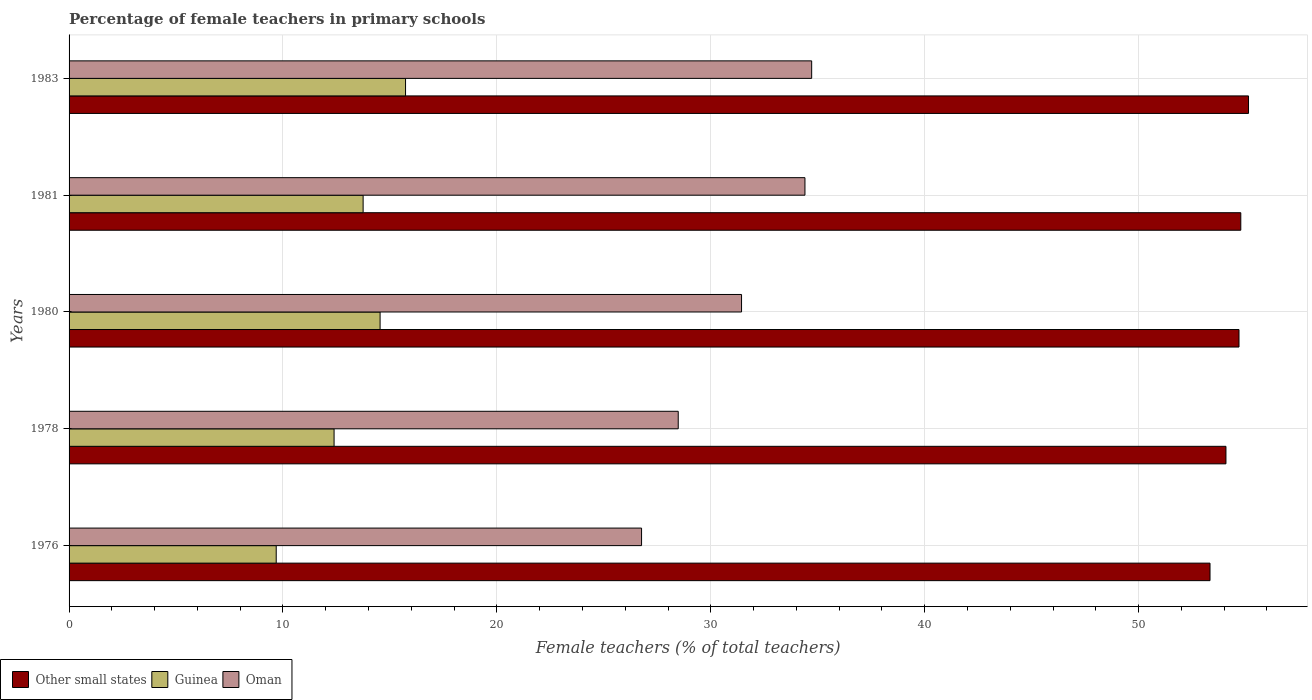How many different coloured bars are there?
Keep it short and to the point. 3. How many groups of bars are there?
Provide a short and direct response. 5. Are the number of bars on each tick of the Y-axis equal?
Your answer should be very brief. Yes. How many bars are there on the 4th tick from the top?
Offer a terse response. 3. In how many cases, is the number of bars for a given year not equal to the number of legend labels?
Your answer should be compact. 0. What is the percentage of female teachers in Oman in 1983?
Offer a very short reply. 34.72. Across all years, what is the maximum percentage of female teachers in Oman?
Make the answer very short. 34.72. Across all years, what is the minimum percentage of female teachers in Guinea?
Give a very brief answer. 9.68. In which year was the percentage of female teachers in Other small states minimum?
Provide a succinct answer. 1976. What is the total percentage of female teachers in Oman in the graph?
Ensure brevity in your answer.  155.8. What is the difference between the percentage of female teachers in Oman in 1976 and that in 1980?
Offer a terse response. -4.67. What is the difference between the percentage of female teachers in Oman in 1981 and the percentage of female teachers in Guinea in 1980?
Your answer should be compact. 19.86. What is the average percentage of female teachers in Guinea per year?
Make the answer very short. 13.22. In the year 1981, what is the difference between the percentage of female teachers in Guinea and percentage of female teachers in Other small states?
Provide a short and direct response. -41.03. In how many years, is the percentage of female teachers in Oman greater than 50 %?
Keep it short and to the point. 0. What is the ratio of the percentage of female teachers in Oman in 1980 to that in 1983?
Provide a succinct answer. 0.91. Is the percentage of female teachers in Oman in 1976 less than that in 1980?
Provide a short and direct response. Yes. What is the difference between the highest and the second highest percentage of female teachers in Guinea?
Offer a terse response. 1.19. What is the difference between the highest and the lowest percentage of female teachers in Guinea?
Your response must be concise. 6.05. In how many years, is the percentage of female teachers in Other small states greater than the average percentage of female teachers in Other small states taken over all years?
Your answer should be compact. 3. Is the sum of the percentage of female teachers in Other small states in 1978 and 1983 greater than the maximum percentage of female teachers in Guinea across all years?
Your answer should be compact. Yes. What does the 2nd bar from the top in 1978 represents?
Your answer should be compact. Guinea. What does the 3rd bar from the bottom in 1983 represents?
Keep it short and to the point. Oman. Is it the case that in every year, the sum of the percentage of female teachers in Other small states and percentage of female teachers in Guinea is greater than the percentage of female teachers in Oman?
Offer a terse response. Yes. Are all the bars in the graph horizontal?
Give a very brief answer. Yes. How many years are there in the graph?
Your answer should be very brief. 5. What is the difference between two consecutive major ticks on the X-axis?
Provide a succinct answer. 10. Where does the legend appear in the graph?
Offer a very short reply. Bottom left. How are the legend labels stacked?
Offer a very short reply. Horizontal. What is the title of the graph?
Your answer should be very brief. Percentage of female teachers in primary schools. Does "Fragile and conflict affected situations" appear as one of the legend labels in the graph?
Ensure brevity in your answer.  No. What is the label or title of the X-axis?
Provide a short and direct response. Female teachers (% of total teachers). What is the Female teachers (% of total teachers) of Other small states in 1976?
Provide a short and direct response. 53.34. What is the Female teachers (% of total teachers) in Guinea in 1976?
Keep it short and to the point. 9.68. What is the Female teachers (% of total teachers) of Oman in 1976?
Provide a succinct answer. 26.76. What is the Female teachers (% of total teachers) in Other small states in 1978?
Your answer should be very brief. 54.08. What is the Female teachers (% of total teachers) of Guinea in 1978?
Give a very brief answer. 12.39. What is the Female teachers (% of total teachers) in Oman in 1978?
Provide a short and direct response. 28.48. What is the Female teachers (% of total teachers) of Other small states in 1980?
Offer a very short reply. 54.69. What is the Female teachers (% of total teachers) of Guinea in 1980?
Your response must be concise. 14.54. What is the Female teachers (% of total teachers) of Oman in 1980?
Give a very brief answer. 31.44. What is the Female teachers (% of total teachers) of Other small states in 1981?
Provide a succinct answer. 54.78. What is the Female teachers (% of total teachers) in Guinea in 1981?
Provide a succinct answer. 13.75. What is the Female teachers (% of total teachers) in Oman in 1981?
Offer a terse response. 34.4. What is the Female teachers (% of total teachers) of Other small states in 1983?
Offer a terse response. 55.14. What is the Female teachers (% of total teachers) of Guinea in 1983?
Ensure brevity in your answer.  15.73. What is the Female teachers (% of total teachers) in Oman in 1983?
Ensure brevity in your answer.  34.72. Across all years, what is the maximum Female teachers (% of total teachers) of Other small states?
Offer a very short reply. 55.14. Across all years, what is the maximum Female teachers (% of total teachers) of Guinea?
Give a very brief answer. 15.73. Across all years, what is the maximum Female teachers (% of total teachers) of Oman?
Make the answer very short. 34.72. Across all years, what is the minimum Female teachers (% of total teachers) in Other small states?
Your answer should be compact. 53.34. Across all years, what is the minimum Female teachers (% of total teachers) in Guinea?
Ensure brevity in your answer.  9.68. Across all years, what is the minimum Female teachers (% of total teachers) in Oman?
Your answer should be very brief. 26.76. What is the total Female teachers (% of total teachers) in Other small states in the graph?
Your answer should be very brief. 272.04. What is the total Female teachers (% of total teachers) of Guinea in the graph?
Provide a succinct answer. 66.09. What is the total Female teachers (% of total teachers) of Oman in the graph?
Your answer should be compact. 155.8. What is the difference between the Female teachers (% of total teachers) of Other small states in 1976 and that in 1978?
Your answer should be very brief. -0.75. What is the difference between the Female teachers (% of total teachers) of Guinea in 1976 and that in 1978?
Make the answer very short. -2.7. What is the difference between the Female teachers (% of total teachers) in Oman in 1976 and that in 1978?
Your answer should be very brief. -1.71. What is the difference between the Female teachers (% of total teachers) of Other small states in 1976 and that in 1980?
Provide a short and direct response. -1.36. What is the difference between the Female teachers (% of total teachers) of Guinea in 1976 and that in 1980?
Make the answer very short. -4.86. What is the difference between the Female teachers (% of total teachers) in Oman in 1976 and that in 1980?
Ensure brevity in your answer.  -4.67. What is the difference between the Female teachers (% of total teachers) in Other small states in 1976 and that in 1981?
Ensure brevity in your answer.  -1.44. What is the difference between the Female teachers (% of total teachers) in Guinea in 1976 and that in 1981?
Offer a terse response. -4.06. What is the difference between the Female teachers (% of total teachers) of Oman in 1976 and that in 1981?
Ensure brevity in your answer.  -7.64. What is the difference between the Female teachers (% of total teachers) in Other small states in 1976 and that in 1983?
Your response must be concise. -1.8. What is the difference between the Female teachers (% of total teachers) in Guinea in 1976 and that in 1983?
Provide a short and direct response. -6.05. What is the difference between the Female teachers (% of total teachers) of Oman in 1976 and that in 1983?
Give a very brief answer. -7.95. What is the difference between the Female teachers (% of total teachers) in Other small states in 1978 and that in 1980?
Keep it short and to the point. -0.61. What is the difference between the Female teachers (% of total teachers) in Guinea in 1978 and that in 1980?
Offer a very short reply. -2.15. What is the difference between the Female teachers (% of total teachers) in Oman in 1978 and that in 1980?
Provide a short and direct response. -2.96. What is the difference between the Female teachers (% of total teachers) in Other small states in 1978 and that in 1981?
Make the answer very short. -0.69. What is the difference between the Female teachers (% of total teachers) in Guinea in 1978 and that in 1981?
Your response must be concise. -1.36. What is the difference between the Female teachers (% of total teachers) of Oman in 1978 and that in 1981?
Keep it short and to the point. -5.92. What is the difference between the Female teachers (% of total teachers) of Other small states in 1978 and that in 1983?
Your answer should be very brief. -1.05. What is the difference between the Female teachers (% of total teachers) of Guinea in 1978 and that in 1983?
Provide a short and direct response. -3.34. What is the difference between the Female teachers (% of total teachers) of Oman in 1978 and that in 1983?
Your answer should be compact. -6.24. What is the difference between the Female teachers (% of total teachers) of Other small states in 1980 and that in 1981?
Give a very brief answer. -0.08. What is the difference between the Female teachers (% of total teachers) in Guinea in 1980 and that in 1981?
Provide a succinct answer. 0.79. What is the difference between the Female teachers (% of total teachers) in Oman in 1980 and that in 1981?
Your answer should be compact. -2.96. What is the difference between the Female teachers (% of total teachers) of Other small states in 1980 and that in 1983?
Ensure brevity in your answer.  -0.44. What is the difference between the Female teachers (% of total teachers) of Guinea in 1980 and that in 1983?
Keep it short and to the point. -1.19. What is the difference between the Female teachers (% of total teachers) in Oman in 1980 and that in 1983?
Make the answer very short. -3.28. What is the difference between the Female teachers (% of total teachers) of Other small states in 1981 and that in 1983?
Offer a terse response. -0.36. What is the difference between the Female teachers (% of total teachers) of Guinea in 1981 and that in 1983?
Your answer should be very brief. -1.98. What is the difference between the Female teachers (% of total teachers) of Oman in 1981 and that in 1983?
Make the answer very short. -0.31. What is the difference between the Female teachers (% of total teachers) of Other small states in 1976 and the Female teachers (% of total teachers) of Guinea in 1978?
Offer a terse response. 40.95. What is the difference between the Female teachers (% of total teachers) of Other small states in 1976 and the Female teachers (% of total teachers) of Oman in 1978?
Provide a succinct answer. 24.86. What is the difference between the Female teachers (% of total teachers) of Guinea in 1976 and the Female teachers (% of total teachers) of Oman in 1978?
Your answer should be very brief. -18.79. What is the difference between the Female teachers (% of total teachers) in Other small states in 1976 and the Female teachers (% of total teachers) in Guinea in 1980?
Ensure brevity in your answer.  38.8. What is the difference between the Female teachers (% of total teachers) in Other small states in 1976 and the Female teachers (% of total teachers) in Oman in 1980?
Offer a terse response. 21.9. What is the difference between the Female teachers (% of total teachers) in Guinea in 1976 and the Female teachers (% of total teachers) in Oman in 1980?
Your answer should be compact. -21.75. What is the difference between the Female teachers (% of total teachers) of Other small states in 1976 and the Female teachers (% of total teachers) of Guinea in 1981?
Make the answer very short. 39.59. What is the difference between the Female teachers (% of total teachers) of Other small states in 1976 and the Female teachers (% of total teachers) of Oman in 1981?
Ensure brevity in your answer.  18.94. What is the difference between the Female teachers (% of total teachers) in Guinea in 1976 and the Female teachers (% of total teachers) in Oman in 1981?
Offer a terse response. -24.72. What is the difference between the Female teachers (% of total teachers) in Other small states in 1976 and the Female teachers (% of total teachers) in Guinea in 1983?
Offer a very short reply. 37.61. What is the difference between the Female teachers (% of total teachers) in Other small states in 1976 and the Female teachers (% of total teachers) in Oman in 1983?
Offer a terse response. 18.62. What is the difference between the Female teachers (% of total teachers) in Guinea in 1976 and the Female teachers (% of total teachers) in Oman in 1983?
Provide a succinct answer. -25.03. What is the difference between the Female teachers (% of total teachers) of Other small states in 1978 and the Female teachers (% of total teachers) of Guinea in 1980?
Make the answer very short. 39.54. What is the difference between the Female teachers (% of total teachers) in Other small states in 1978 and the Female teachers (% of total teachers) in Oman in 1980?
Offer a terse response. 22.65. What is the difference between the Female teachers (% of total teachers) in Guinea in 1978 and the Female teachers (% of total teachers) in Oman in 1980?
Offer a very short reply. -19.05. What is the difference between the Female teachers (% of total teachers) in Other small states in 1978 and the Female teachers (% of total teachers) in Guinea in 1981?
Offer a very short reply. 40.34. What is the difference between the Female teachers (% of total teachers) of Other small states in 1978 and the Female teachers (% of total teachers) of Oman in 1981?
Give a very brief answer. 19.68. What is the difference between the Female teachers (% of total teachers) in Guinea in 1978 and the Female teachers (% of total teachers) in Oman in 1981?
Offer a very short reply. -22.01. What is the difference between the Female teachers (% of total teachers) in Other small states in 1978 and the Female teachers (% of total teachers) in Guinea in 1983?
Offer a very short reply. 38.35. What is the difference between the Female teachers (% of total teachers) in Other small states in 1978 and the Female teachers (% of total teachers) in Oman in 1983?
Offer a very short reply. 19.37. What is the difference between the Female teachers (% of total teachers) in Guinea in 1978 and the Female teachers (% of total teachers) in Oman in 1983?
Keep it short and to the point. -22.33. What is the difference between the Female teachers (% of total teachers) of Other small states in 1980 and the Female teachers (% of total teachers) of Guinea in 1981?
Give a very brief answer. 40.95. What is the difference between the Female teachers (% of total teachers) in Other small states in 1980 and the Female teachers (% of total teachers) in Oman in 1981?
Make the answer very short. 20.29. What is the difference between the Female teachers (% of total teachers) in Guinea in 1980 and the Female teachers (% of total teachers) in Oman in 1981?
Provide a short and direct response. -19.86. What is the difference between the Female teachers (% of total teachers) of Other small states in 1980 and the Female teachers (% of total teachers) of Guinea in 1983?
Provide a short and direct response. 38.96. What is the difference between the Female teachers (% of total teachers) of Other small states in 1980 and the Female teachers (% of total teachers) of Oman in 1983?
Your response must be concise. 19.98. What is the difference between the Female teachers (% of total teachers) in Guinea in 1980 and the Female teachers (% of total teachers) in Oman in 1983?
Offer a very short reply. -20.18. What is the difference between the Female teachers (% of total teachers) in Other small states in 1981 and the Female teachers (% of total teachers) in Guinea in 1983?
Make the answer very short. 39.05. What is the difference between the Female teachers (% of total teachers) in Other small states in 1981 and the Female teachers (% of total teachers) in Oman in 1983?
Offer a terse response. 20.06. What is the difference between the Female teachers (% of total teachers) of Guinea in 1981 and the Female teachers (% of total teachers) of Oman in 1983?
Ensure brevity in your answer.  -20.97. What is the average Female teachers (% of total teachers) of Other small states per year?
Provide a succinct answer. 54.41. What is the average Female teachers (% of total teachers) in Guinea per year?
Make the answer very short. 13.22. What is the average Female teachers (% of total teachers) in Oman per year?
Your answer should be very brief. 31.16. In the year 1976, what is the difference between the Female teachers (% of total teachers) in Other small states and Female teachers (% of total teachers) in Guinea?
Ensure brevity in your answer.  43.66. In the year 1976, what is the difference between the Female teachers (% of total teachers) in Other small states and Female teachers (% of total teachers) in Oman?
Give a very brief answer. 26.58. In the year 1976, what is the difference between the Female teachers (% of total teachers) of Guinea and Female teachers (% of total teachers) of Oman?
Your answer should be compact. -17.08. In the year 1978, what is the difference between the Female teachers (% of total teachers) of Other small states and Female teachers (% of total teachers) of Guinea?
Keep it short and to the point. 41.7. In the year 1978, what is the difference between the Female teachers (% of total teachers) in Other small states and Female teachers (% of total teachers) in Oman?
Offer a very short reply. 25.61. In the year 1978, what is the difference between the Female teachers (% of total teachers) in Guinea and Female teachers (% of total teachers) in Oman?
Make the answer very short. -16.09. In the year 1980, what is the difference between the Female teachers (% of total teachers) in Other small states and Female teachers (% of total teachers) in Guinea?
Make the answer very short. 40.15. In the year 1980, what is the difference between the Female teachers (% of total teachers) of Other small states and Female teachers (% of total teachers) of Oman?
Your answer should be very brief. 23.26. In the year 1980, what is the difference between the Female teachers (% of total teachers) of Guinea and Female teachers (% of total teachers) of Oman?
Offer a very short reply. -16.9. In the year 1981, what is the difference between the Female teachers (% of total teachers) of Other small states and Female teachers (% of total teachers) of Guinea?
Your answer should be very brief. 41.03. In the year 1981, what is the difference between the Female teachers (% of total teachers) of Other small states and Female teachers (% of total teachers) of Oman?
Provide a succinct answer. 20.38. In the year 1981, what is the difference between the Female teachers (% of total teachers) of Guinea and Female teachers (% of total teachers) of Oman?
Provide a short and direct response. -20.66. In the year 1983, what is the difference between the Female teachers (% of total teachers) in Other small states and Female teachers (% of total teachers) in Guinea?
Your answer should be compact. 39.41. In the year 1983, what is the difference between the Female teachers (% of total teachers) of Other small states and Female teachers (% of total teachers) of Oman?
Provide a succinct answer. 20.42. In the year 1983, what is the difference between the Female teachers (% of total teachers) of Guinea and Female teachers (% of total teachers) of Oman?
Keep it short and to the point. -18.99. What is the ratio of the Female teachers (% of total teachers) of Other small states in 1976 to that in 1978?
Offer a terse response. 0.99. What is the ratio of the Female teachers (% of total teachers) of Guinea in 1976 to that in 1978?
Your response must be concise. 0.78. What is the ratio of the Female teachers (% of total teachers) in Oman in 1976 to that in 1978?
Offer a very short reply. 0.94. What is the ratio of the Female teachers (% of total teachers) of Other small states in 1976 to that in 1980?
Keep it short and to the point. 0.98. What is the ratio of the Female teachers (% of total teachers) in Guinea in 1976 to that in 1980?
Make the answer very short. 0.67. What is the ratio of the Female teachers (% of total teachers) in Oman in 1976 to that in 1980?
Provide a short and direct response. 0.85. What is the ratio of the Female teachers (% of total teachers) of Other small states in 1976 to that in 1981?
Keep it short and to the point. 0.97. What is the ratio of the Female teachers (% of total teachers) in Guinea in 1976 to that in 1981?
Give a very brief answer. 0.7. What is the ratio of the Female teachers (% of total teachers) of Oman in 1976 to that in 1981?
Your answer should be compact. 0.78. What is the ratio of the Female teachers (% of total teachers) of Other small states in 1976 to that in 1983?
Offer a terse response. 0.97. What is the ratio of the Female teachers (% of total teachers) of Guinea in 1976 to that in 1983?
Your response must be concise. 0.62. What is the ratio of the Female teachers (% of total teachers) of Oman in 1976 to that in 1983?
Your answer should be compact. 0.77. What is the ratio of the Female teachers (% of total teachers) of Other small states in 1978 to that in 1980?
Your response must be concise. 0.99. What is the ratio of the Female teachers (% of total teachers) in Guinea in 1978 to that in 1980?
Make the answer very short. 0.85. What is the ratio of the Female teachers (% of total teachers) in Oman in 1978 to that in 1980?
Your answer should be very brief. 0.91. What is the ratio of the Female teachers (% of total teachers) in Other small states in 1978 to that in 1981?
Ensure brevity in your answer.  0.99. What is the ratio of the Female teachers (% of total teachers) of Guinea in 1978 to that in 1981?
Your answer should be compact. 0.9. What is the ratio of the Female teachers (% of total teachers) of Oman in 1978 to that in 1981?
Provide a short and direct response. 0.83. What is the ratio of the Female teachers (% of total teachers) of Other small states in 1978 to that in 1983?
Keep it short and to the point. 0.98. What is the ratio of the Female teachers (% of total teachers) in Guinea in 1978 to that in 1983?
Your answer should be very brief. 0.79. What is the ratio of the Female teachers (% of total teachers) of Oman in 1978 to that in 1983?
Ensure brevity in your answer.  0.82. What is the ratio of the Female teachers (% of total teachers) of Other small states in 1980 to that in 1981?
Keep it short and to the point. 1. What is the ratio of the Female teachers (% of total teachers) in Guinea in 1980 to that in 1981?
Offer a terse response. 1.06. What is the ratio of the Female teachers (% of total teachers) in Oman in 1980 to that in 1981?
Ensure brevity in your answer.  0.91. What is the ratio of the Female teachers (% of total teachers) in Other small states in 1980 to that in 1983?
Make the answer very short. 0.99. What is the ratio of the Female teachers (% of total teachers) in Guinea in 1980 to that in 1983?
Keep it short and to the point. 0.92. What is the ratio of the Female teachers (% of total teachers) of Oman in 1980 to that in 1983?
Your answer should be very brief. 0.91. What is the ratio of the Female teachers (% of total teachers) in Guinea in 1981 to that in 1983?
Your answer should be compact. 0.87. What is the ratio of the Female teachers (% of total teachers) of Oman in 1981 to that in 1983?
Your answer should be compact. 0.99. What is the difference between the highest and the second highest Female teachers (% of total teachers) in Other small states?
Provide a short and direct response. 0.36. What is the difference between the highest and the second highest Female teachers (% of total teachers) of Guinea?
Provide a short and direct response. 1.19. What is the difference between the highest and the second highest Female teachers (% of total teachers) of Oman?
Your answer should be very brief. 0.31. What is the difference between the highest and the lowest Female teachers (% of total teachers) of Other small states?
Provide a succinct answer. 1.8. What is the difference between the highest and the lowest Female teachers (% of total teachers) in Guinea?
Your response must be concise. 6.05. What is the difference between the highest and the lowest Female teachers (% of total teachers) in Oman?
Keep it short and to the point. 7.95. 